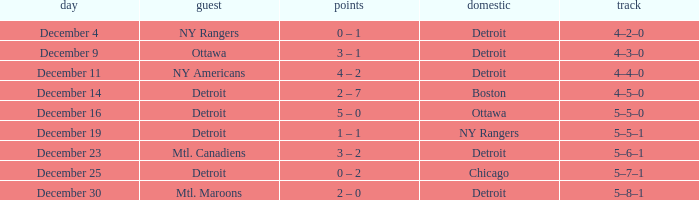What record has detroit as the home and mtl. maroons as the visitor? 5–8–1. 